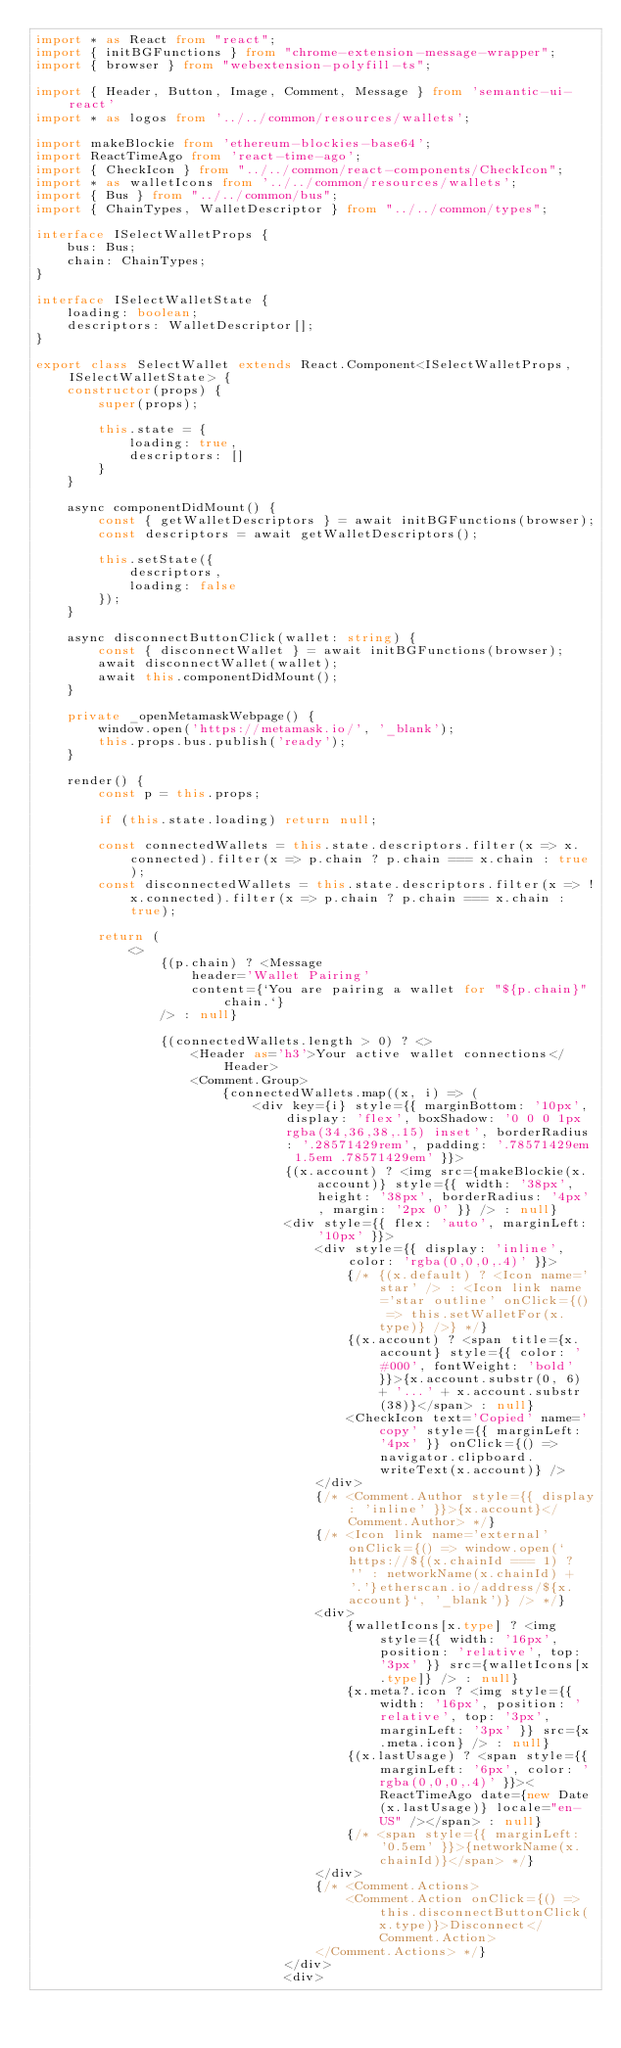Convert code to text. <code><loc_0><loc_0><loc_500><loc_500><_TypeScript_>import * as React from "react";
import { initBGFunctions } from "chrome-extension-message-wrapper";
import { browser } from "webextension-polyfill-ts";

import { Header, Button, Image, Comment, Message } from 'semantic-ui-react'
import * as logos from '../../common/resources/wallets';

import makeBlockie from 'ethereum-blockies-base64';
import ReactTimeAgo from 'react-time-ago';
import { CheckIcon } from "../../common/react-components/CheckIcon";
import * as walletIcons from '../../common/resources/wallets';
import { Bus } from "../../common/bus";
import { ChainTypes, WalletDescriptor } from "../../common/types";

interface ISelectWalletProps {
    bus: Bus;
    chain: ChainTypes;
}

interface ISelectWalletState {
    loading: boolean;
    descriptors: WalletDescriptor[];
}

export class SelectWallet extends React.Component<ISelectWalletProps, ISelectWalletState> {
    constructor(props) {
        super(props);

        this.state = {
            loading: true,
            descriptors: []
        }
    }

    async componentDidMount() {
        const { getWalletDescriptors } = await initBGFunctions(browser);
        const descriptors = await getWalletDescriptors();

        this.setState({
            descriptors,
            loading: false
        });
    }

    async disconnectButtonClick(wallet: string) {
        const { disconnectWallet } = await initBGFunctions(browser);
        await disconnectWallet(wallet);
        await this.componentDidMount();
    }

    private _openMetamaskWebpage() {
        window.open('https://metamask.io/', '_blank');
        this.props.bus.publish('ready');
    }

    render() {
        const p = this.props;

        if (this.state.loading) return null;

        const connectedWallets = this.state.descriptors.filter(x => x.connected).filter(x => p.chain ? p.chain === x.chain : true);
        const disconnectedWallets = this.state.descriptors.filter(x => !x.connected).filter(x => p.chain ? p.chain === x.chain : true);

        return (
            <>
                {(p.chain) ? <Message
                    header='Wallet Pairing'
                    content={`You are pairing a wallet for "${p.chain}" chain.`}
                /> : null}

                {(connectedWallets.length > 0) ? <>
                    <Header as='h3'>Your active wallet connections</Header>
                    <Comment.Group>
                        {connectedWallets.map((x, i) => (
                            <div key={i} style={{ marginBottom: '10px', display: 'flex', boxShadow: '0 0 0 1px rgba(34,36,38,.15) inset', borderRadius: '.28571429rem', padding: '.78571429em 1.5em .78571429em' }}>
                                {(x.account) ? <img src={makeBlockie(x.account)} style={{ width: '38px', height: '38px', borderRadius: '4px', margin: '2px 0' }} /> : null}
                                <div style={{ flex: 'auto', marginLeft: '10px' }}>
                                    <div style={{ display: 'inline', color: 'rgba(0,0,0,.4)' }}>
                                        {/* {(x.default) ? <Icon name='star' /> : <Icon link name='star outline' onClick={() => this.setWalletFor(x.type)} />} */}
                                        {(x.account) ? <span title={x.account} style={{ color: '#000', fontWeight: 'bold' }}>{x.account.substr(0, 6) + '...' + x.account.substr(38)}</span> : null}
                                        <CheckIcon text='Copied' name='copy' style={{ marginLeft: '4px' }} onClick={() => navigator.clipboard.writeText(x.account)} />
                                    </div>
                                    {/* <Comment.Author style={{ display: 'inline' }}>{x.account}</Comment.Author> */}
                                    {/* <Icon link name='external' onClick={() => window.open(`https://${(x.chainId === 1) ? '' : networkName(x.chainId) + '.'}etherscan.io/address/${x.account}`, '_blank')} /> */}
                                    <div>
                                        {walletIcons[x.type] ? <img style={{ width: '16px', position: 'relative', top: '3px' }} src={walletIcons[x.type]} /> : null}
                                        {x.meta?.icon ? <img style={{ width: '16px', position: 'relative', top: '3px', marginLeft: '3px' }} src={x.meta.icon} /> : null}
                                        {(x.lastUsage) ? <span style={{ marginLeft: '6px', color: 'rgba(0,0,0,.4)' }}><ReactTimeAgo date={new Date(x.lastUsage)} locale="en-US" /></span> : null}
                                        {/* <span style={{ marginLeft: '0.5em' }}>{networkName(x.chainId)}</span> */}
                                    </div>
                                    {/* <Comment.Actions>
                                        <Comment.Action onClick={() => this.disconnectButtonClick(x.type)}>Disconnect</Comment.Action>
                                    </Comment.Actions> */}
                                </div>
                                <div></code> 